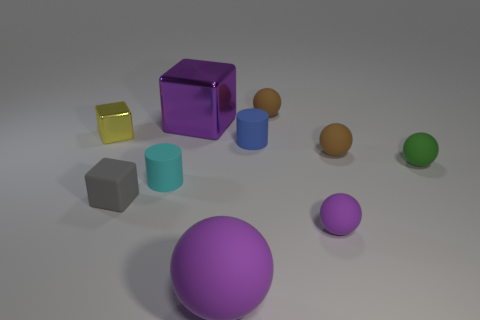Is the number of purple shiny things greater than the number of big red rubber cubes?
Keep it short and to the point. Yes. How many objects are in front of the tiny yellow cube and behind the small gray thing?
Keep it short and to the point. 4. The purple thing behind the small brown matte thing that is on the right side of the tiny sphere in front of the green rubber sphere is what shape?
Ensure brevity in your answer.  Cube. Is there anything else that is the same shape as the small yellow object?
Your answer should be compact. Yes. What number of cubes are purple things or cyan things?
Provide a short and direct response. 1. There is a shiny thing right of the cyan cylinder; does it have the same color as the large matte sphere?
Offer a terse response. Yes. What material is the thing that is to the left of the cube in front of the small green sphere in front of the large purple metal cube?
Provide a short and direct response. Metal. Does the green matte ball have the same size as the cyan matte thing?
Your response must be concise. Yes. There is a big shiny block; is its color the same as the large object that is in front of the tiny green sphere?
Your response must be concise. Yes. What is the shape of the tiny purple object that is the same material as the small gray thing?
Offer a terse response. Sphere. 